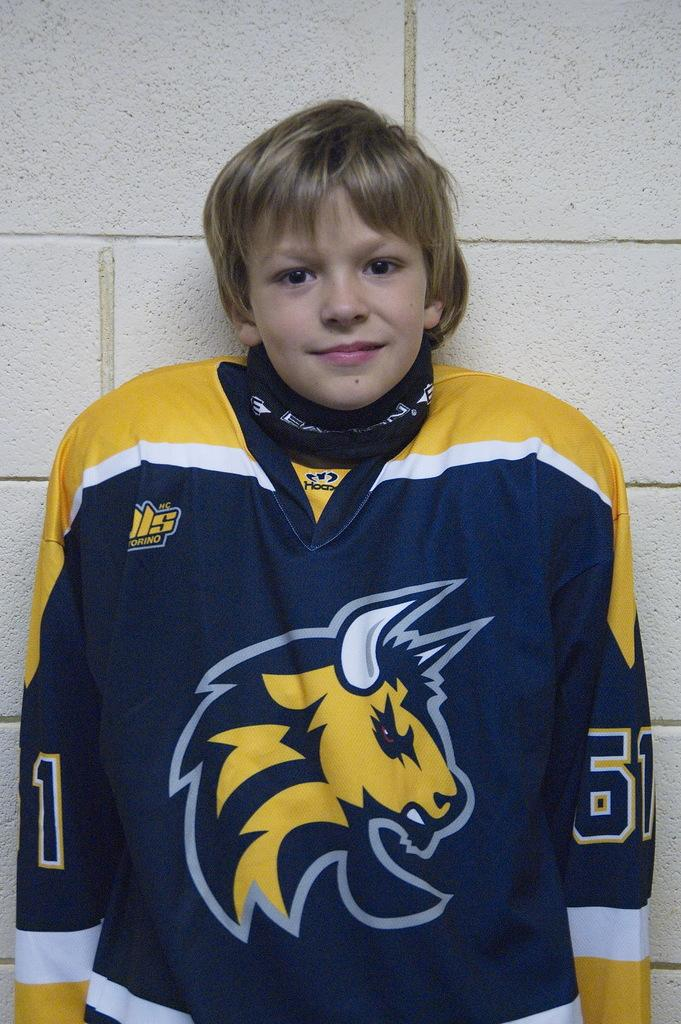What is the main subject of the image? The main subject of the image is a kid. What is the kid doing in the image? The kid is standing in the image. What is the kid wearing in the image? The kid is wearing a T-shirt in the image. What can be seen in the background of the image? There is a wall in the background of the image. What is the title of the book the kid is reading in the image? There is no book present in the image, so there is no title to reference. 